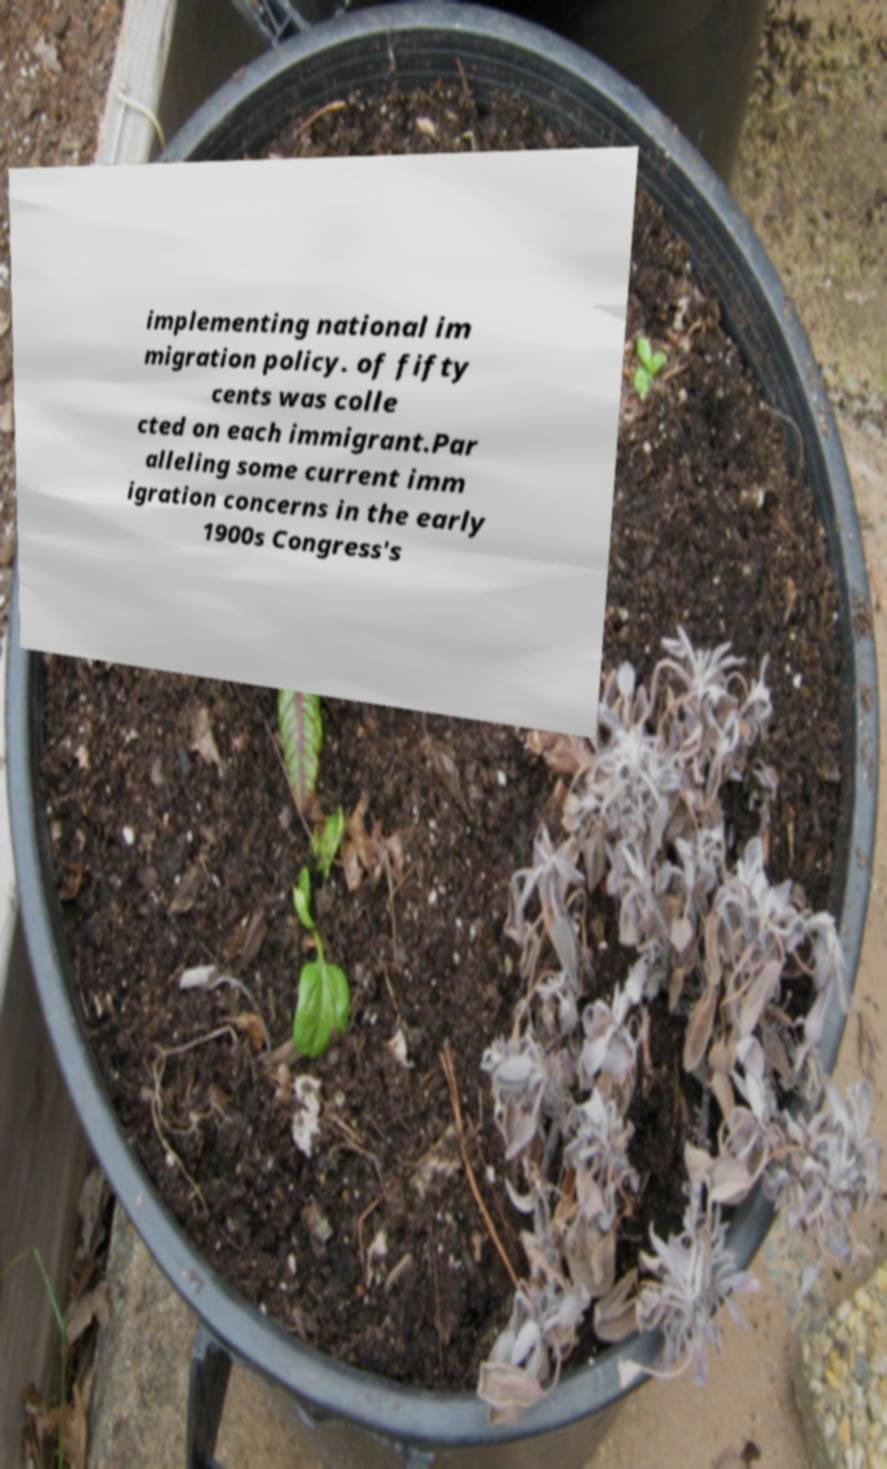Can you read and provide the text displayed in the image?This photo seems to have some interesting text. Can you extract and type it out for me? implementing national im migration policy. of fifty cents was colle cted on each immigrant.Par alleling some current imm igration concerns in the early 1900s Congress's 